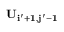<formula> <loc_0><loc_0><loc_500><loc_500>U _ { i ^ { \prime } + 1 , j ^ { \prime } - 1 }</formula> 